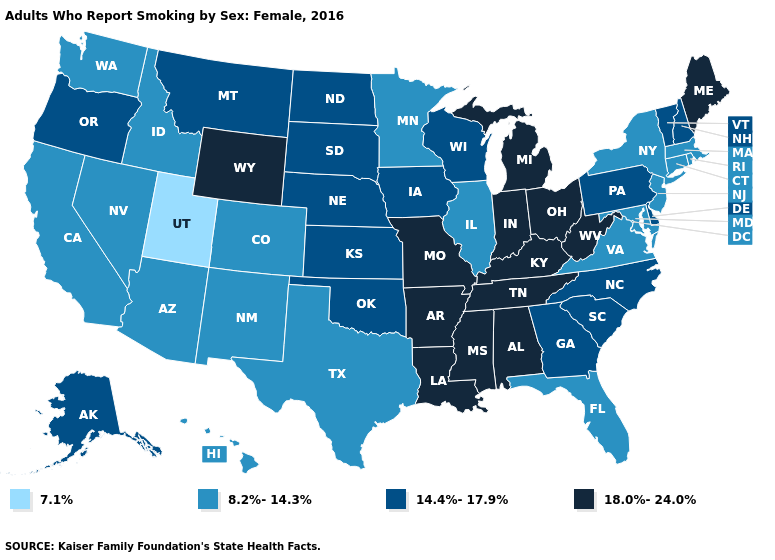Does Alaska have the same value as Alabama?
Be succinct. No. What is the value of Missouri?
Keep it brief. 18.0%-24.0%. Name the states that have a value in the range 18.0%-24.0%?
Be succinct. Alabama, Arkansas, Indiana, Kentucky, Louisiana, Maine, Michigan, Mississippi, Missouri, Ohio, Tennessee, West Virginia, Wyoming. Name the states that have a value in the range 14.4%-17.9%?
Answer briefly. Alaska, Delaware, Georgia, Iowa, Kansas, Montana, Nebraska, New Hampshire, North Carolina, North Dakota, Oklahoma, Oregon, Pennsylvania, South Carolina, South Dakota, Vermont, Wisconsin. What is the lowest value in states that border California?
Give a very brief answer. 8.2%-14.3%. What is the value of Connecticut?
Write a very short answer. 8.2%-14.3%. Does Massachusetts have the lowest value in the USA?
Quick response, please. No. Does Utah have the lowest value in the USA?
Keep it brief. Yes. Does Alaska have the highest value in the West?
Answer briefly. No. Is the legend a continuous bar?
Concise answer only. No. What is the value of North Carolina?
Write a very short answer. 14.4%-17.9%. What is the value of Washington?
Give a very brief answer. 8.2%-14.3%. Which states have the lowest value in the West?
Short answer required. Utah. Among the states that border Utah , does Idaho have the lowest value?
Be succinct. Yes. 